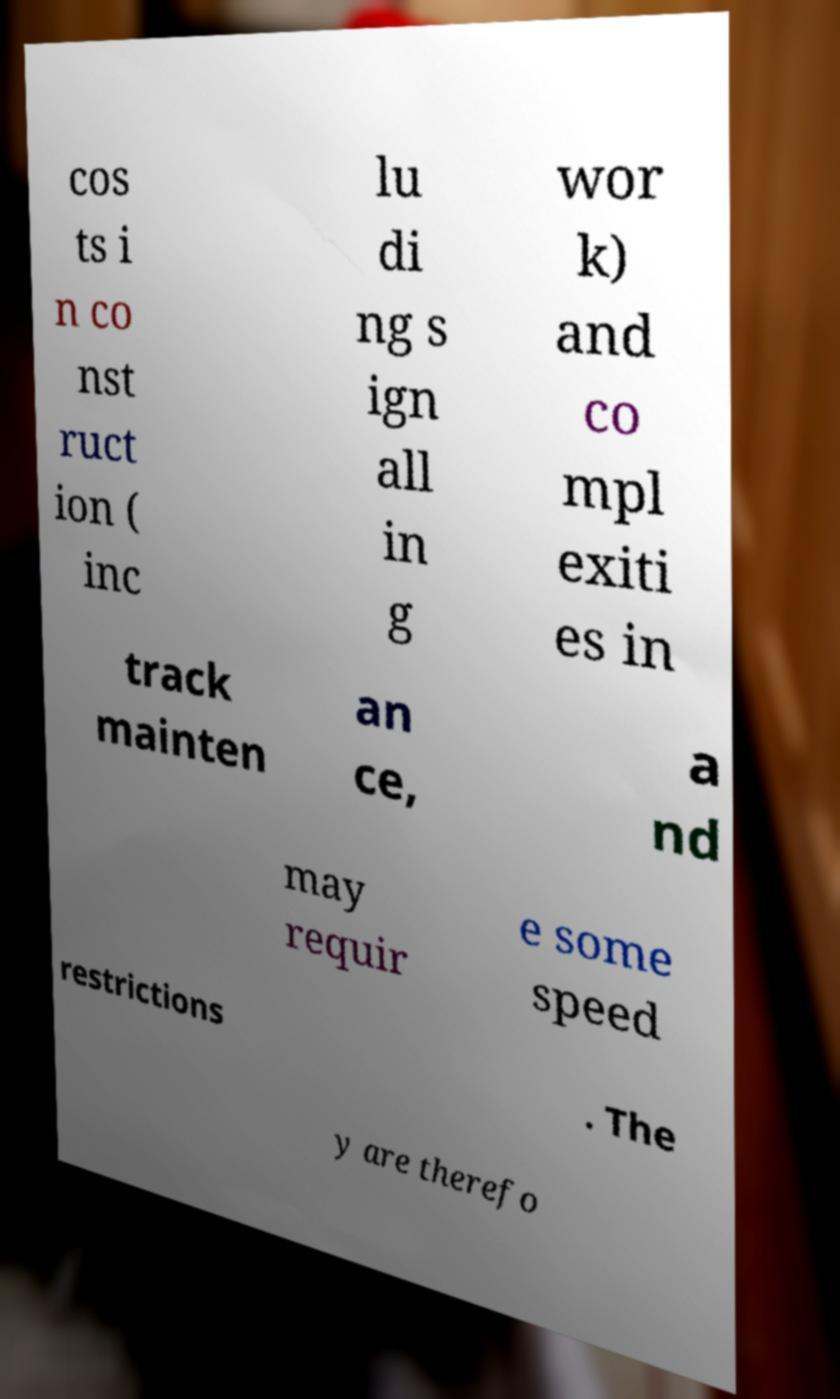What messages or text are displayed in this image? I need them in a readable, typed format. cos ts i n co nst ruct ion ( inc lu di ng s ign all in g wor k) and co mpl exiti es in track mainten an ce, a nd may requir e some speed restrictions . The y are therefo 